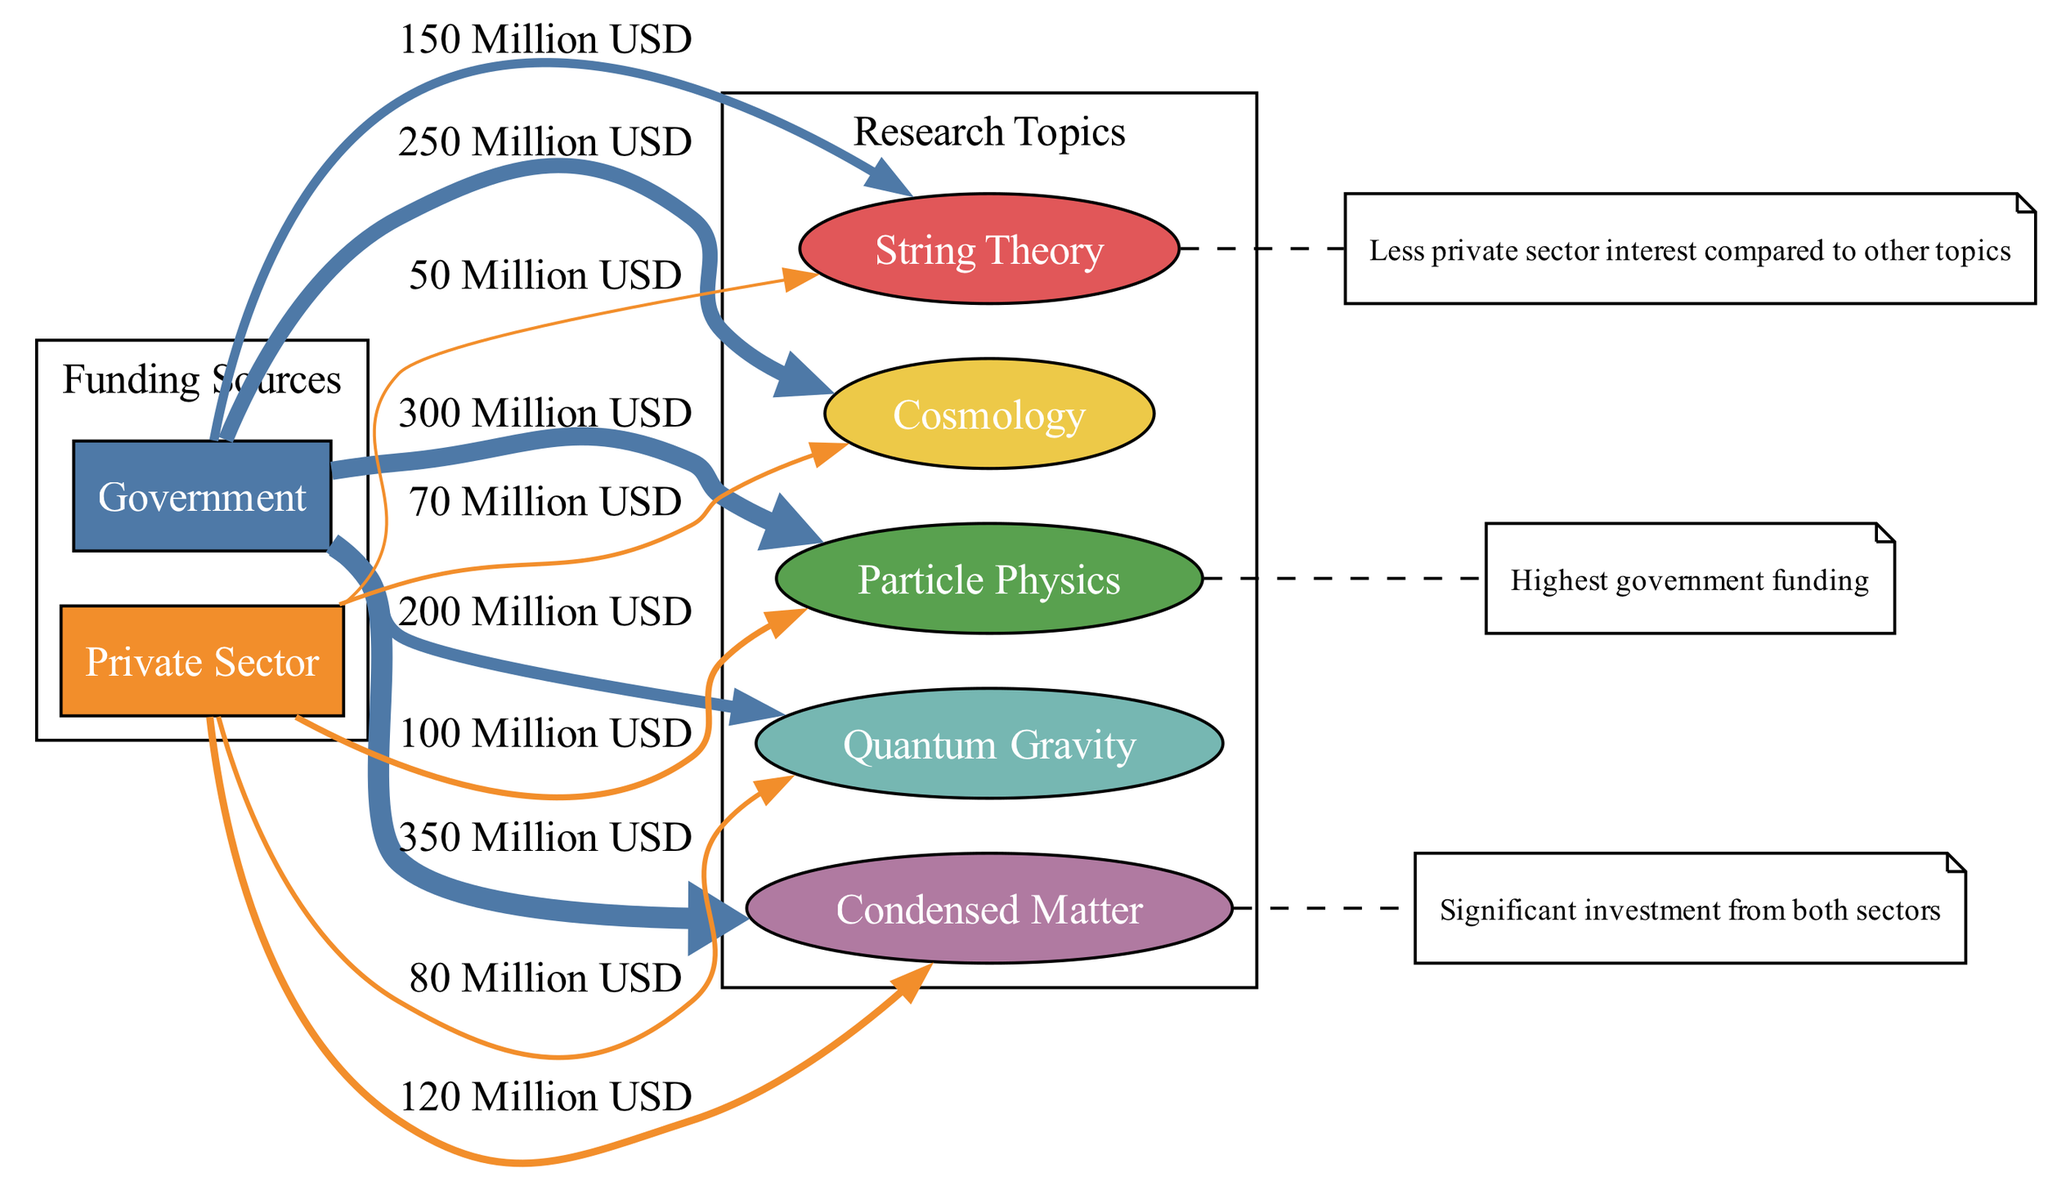What is the total investment from the Government in Particle Physics? The diagram shows that the Government has invested 300 million USD in Particle Physics, which can be found directly associated with the Government node and the Particle Physics node.
Answer: 300 million USD Which theoretical physics research topic received the highest funding from the Private Sector? Looking at the Private Sector investments in the diagram, Particle Physics with an investment of 100 million USD is the highest, compared to other topics.
Answer: Particle Physics How much money was allocated to String Theory by the Government? The amount allocated to String Theory by the Government is directly indicated at the connection between the Government node and the String Theory node, showing 150 million USD.
Answer: 150 million USD Which research topic has the lowest total funding between Government and Private Sector contributions? By comparing all the investments, String Theory has the lowest combined funding of 200 million USD (150 million from Government and 50 million from Private Sector).
Answer: String Theory What is the investment difference between Government and Private Sector in Quantum Gravity? For Quantum Gravity, the Government invested 200 million USD while the Private Sector invested 80 million USD, leading to a difference of 120 million USD between the two sources.
Answer: 120 million USD How many research topics are funded by the Government? The diagram lists five research topics (String Theory, Quantum Gravity, Particle Physics, Cosmology, Condensed Matter) that are funded by the Government, indicating five distinct connections.
Answer: 5 What color represents the funding source 'Private Sector' in the diagram? The color associated with the Private Sector node in the diagram is orange, which is used both for the node itself and the edges indicating investment amounts.
Answer: Orange Which research topic has a significant investment from both sectors? According to the annotations in the diagram, Condensed Matter is highlighted as having significant investment from both the Government and Private Sector, suggesting balanced funding.
Answer: Condensed Matter 